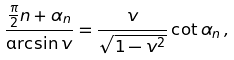<formula> <loc_0><loc_0><loc_500><loc_500>\frac { \frac { \pi } { 2 } n + \alpha _ { n } } { \arcsin v } = \frac { v } { \sqrt { 1 - v ^ { 2 } } } \cot \alpha _ { n } \, ,</formula> 